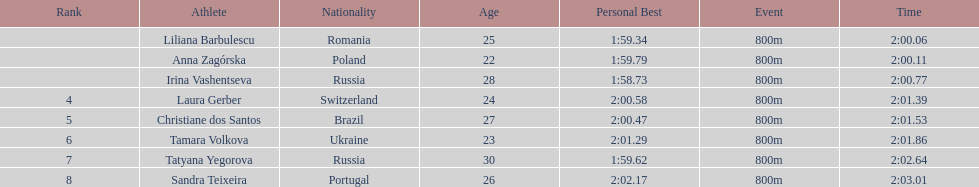What is the name of the top finalist of this semifinals heat? Liliana Barbulescu. Could you parse the entire table? {'header': ['Rank', 'Athlete', 'Nationality', 'Age', 'Personal Best', 'Event', 'Time'], 'rows': [['', 'Liliana Barbulescu', 'Romania', '25', '1:59.34', '800m', '2:00.06'], ['', 'Anna Zagórska', 'Poland', '22', '1:59.79', '800m', '2:00.11'], ['', 'Irina Vashentseva', 'Russia', '28', '1:58.73', '800m', '2:00.77'], ['4', 'Laura Gerber', 'Switzerland', '24', '2:00.58', '800m', '2:01.39'], ['5', 'Christiane dos Santos', 'Brazil', '27', '2:00.47', '800m', '2:01.53'], ['6', 'Tamara Volkova', 'Ukraine', '23', '2:01.29', '800m', '2:01.86'], ['7', 'Tatyana Yegorova', 'Russia', '30', '1:59.62', '800m', '2:02.64'], ['8', 'Sandra Teixeira', 'Portugal', '26', '2:02.17', '800m', '2:03.01']]} 